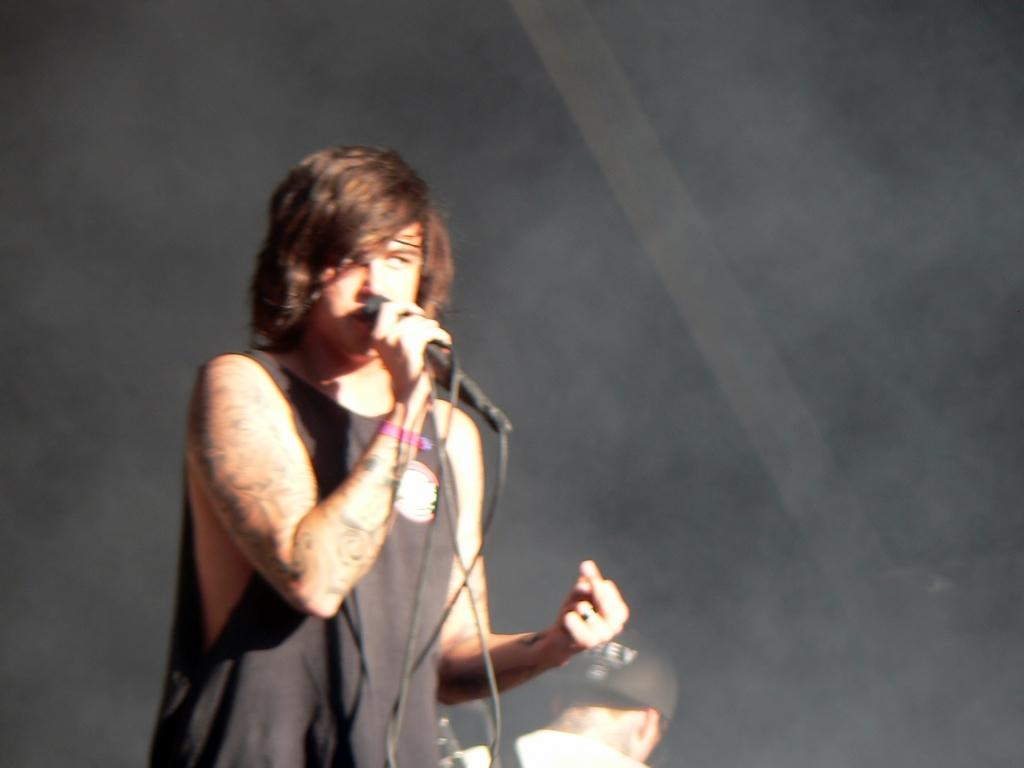What is the man in the image wearing? The man is wearing a black T-shirt. What is the man holding in his hand? The man is holding a mic in his hand. Can you describe the other person in the image? Unfortunately, the provided facts do not give any information about the other person in the image. What type of oil can be seen dripping from the man's T-shirt in the image? There is no oil present in the image, and the man's T-shirt is not depicted as having any oil on it. 